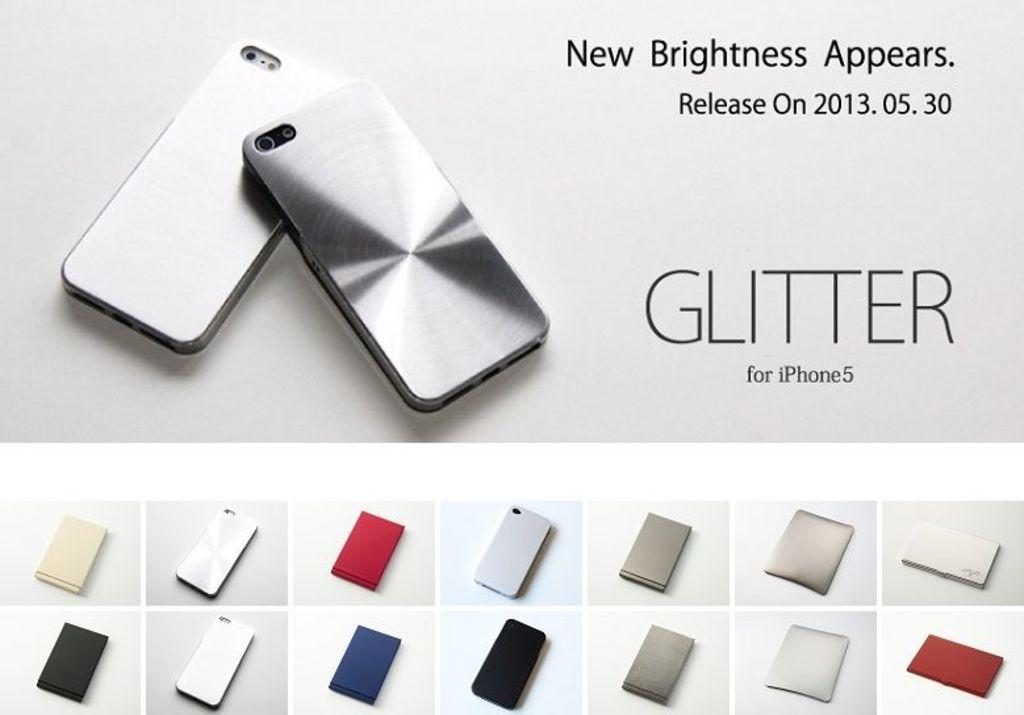<image>
Provide a brief description of the given image. Multiple iPhone 5 cases are shown confirming a 05.30.2013 release date 